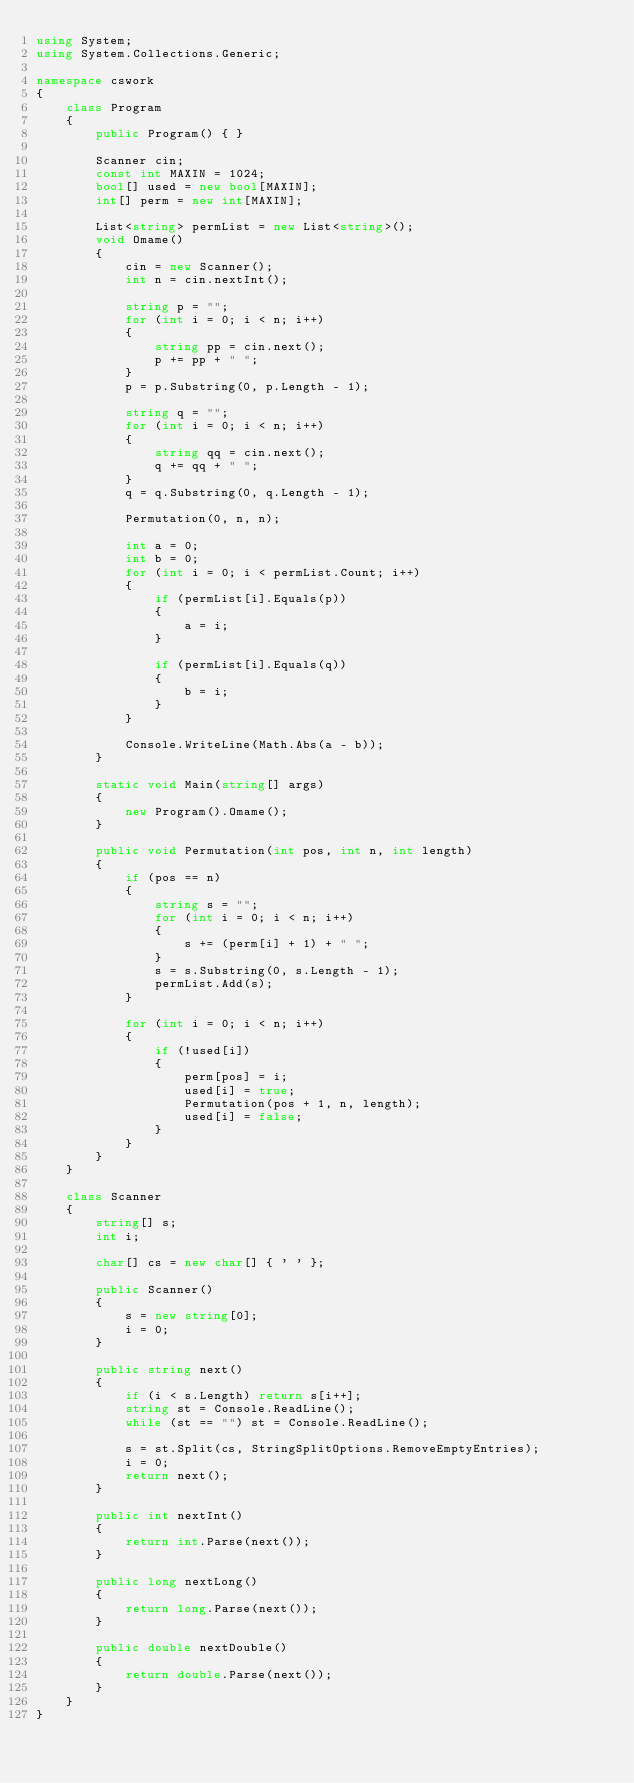Convert code to text. <code><loc_0><loc_0><loc_500><loc_500><_C#_>using System;
using System.Collections.Generic;

namespace cswork
{
    class Program
    {
        public Program() { }

        Scanner cin;
        const int MAXIN = 1024;
        bool[] used = new bool[MAXIN];
        int[] perm = new int[MAXIN];

        List<string> permList = new List<string>();
        void Omame()
        {
            cin = new Scanner();
            int n = cin.nextInt();

            string p = "";
            for (int i = 0; i < n; i++)
            {
                string pp = cin.next();
                p += pp + " ";
            }
            p = p.Substring(0, p.Length - 1);

            string q = "";
            for (int i = 0; i < n; i++)
            {
                string qq = cin.next();
                q += qq + " ";
            }
            q = q.Substring(0, q.Length - 1);

            Permutation(0, n, n);

            int a = 0;
            int b = 0;
            for (int i = 0; i < permList.Count; i++)
            {
                if (permList[i].Equals(p))
                {
                    a = i;
                }
                
                if (permList[i].Equals(q))
                {
                    b = i;
                }
            }

            Console.WriteLine(Math.Abs(a - b));
        }

        static void Main(string[] args)
        {
            new Program().Omame();
        }

        public void Permutation(int pos, int n, int length)
        {
            if (pos == n)
            {
                string s = "";
                for (int i = 0; i < n; i++)
                {
                    s += (perm[i] + 1) + " ";
                }
                s = s.Substring(0, s.Length - 1);
                permList.Add(s);
            }

            for (int i = 0; i < n; i++)
            {
                if (!used[i])
                {
                    perm[pos] = i;
                    used[i] = true;
                    Permutation(pos + 1, n, length);
                    used[i] = false;
                }
            }
        }
    }

    class Scanner
    {
        string[] s;
        int i;

        char[] cs = new char[] { ' ' };

        public Scanner()
        {
            s = new string[0];
            i = 0;
        }

        public string next()
        {
            if (i < s.Length) return s[i++];
            string st = Console.ReadLine();
            while (st == "") st = Console.ReadLine();

            s = st.Split(cs, StringSplitOptions.RemoveEmptyEntries);
            i = 0;
            return next();
        }

        public int nextInt()
        {
            return int.Parse(next());
        }

        public long nextLong()
        {
            return long.Parse(next());
        }

        public double nextDouble()
        {
            return double.Parse(next());
        }
    }
}</code> 